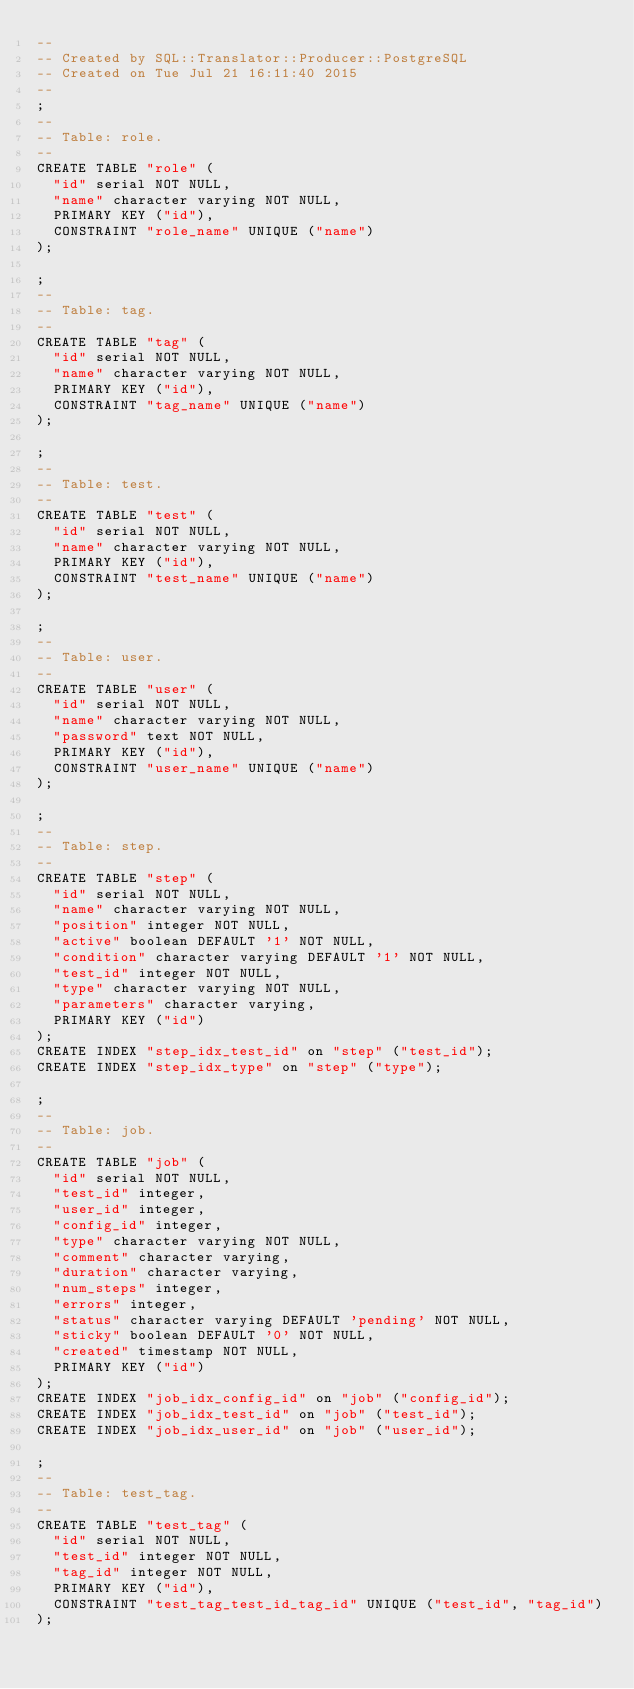<code> <loc_0><loc_0><loc_500><loc_500><_SQL_>-- 
-- Created by SQL::Translator::Producer::PostgreSQL
-- Created on Tue Jul 21 16:11:40 2015
-- 
;
--
-- Table: role.
--
CREATE TABLE "role" (
  "id" serial NOT NULL,
  "name" character varying NOT NULL,
  PRIMARY KEY ("id"),
  CONSTRAINT "role_name" UNIQUE ("name")
);

;
--
-- Table: tag.
--
CREATE TABLE "tag" (
  "id" serial NOT NULL,
  "name" character varying NOT NULL,
  PRIMARY KEY ("id"),
  CONSTRAINT "tag_name" UNIQUE ("name")
);

;
--
-- Table: test.
--
CREATE TABLE "test" (
  "id" serial NOT NULL,
  "name" character varying NOT NULL,
  PRIMARY KEY ("id"),
  CONSTRAINT "test_name" UNIQUE ("name")
);

;
--
-- Table: user.
--
CREATE TABLE "user" (
  "id" serial NOT NULL,
  "name" character varying NOT NULL,
  "password" text NOT NULL,
  PRIMARY KEY ("id"),
  CONSTRAINT "user_name" UNIQUE ("name")
);

;
--
-- Table: step.
--
CREATE TABLE "step" (
  "id" serial NOT NULL,
  "name" character varying NOT NULL,
  "position" integer NOT NULL,
  "active" boolean DEFAULT '1' NOT NULL,
  "condition" character varying DEFAULT '1' NOT NULL,
  "test_id" integer NOT NULL,
  "type" character varying NOT NULL,
  "parameters" character varying,
  PRIMARY KEY ("id")
);
CREATE INDEX "step_idx_test_id" on "step" ("test_id");
CREATE INDEX "step_idx_type" on "step" ("type");

;
--
-- Table: job.
--
CREATE TABLE "job" (
  "id" serial NOT NULL,
  "test_id" integer,
  "user_id" integer,
  "config_id" integer,
  "type" character varying NOT NULL,
  "comment" character varying,
  "duration" character varying,
  "num_steps" integer,
  "errors" integer,
  "status" character varying DEFAULT 'pending' NOT NULL,
  "sticky" boolean DEFAULT '0' NOT NULL,
  "created" timestamp NOT NULL,
  PRIMARY KEY ("id")
);
CREATE INDEX "job_idx_config_id" on "job" ("config_id");
CREATE INDEX "job_idx_test_id" on "job" ("test_id");
CREATE INDEX "job_idx_user_id" on "job" ("user_id");

;
--
-- Table: test_tag.
--
CREATE TABLE "test_tag" (
  "id" serial NOT NULL,
  "test_id" integer NOT NULL,
  "tag_id" integer NOT NULL,
  PRIMARY KEY ("id"),
  CONSTRAINT "test_tag_test_id_tag_id" UNIQUE ("test_id", "tag_id")
);</code> 